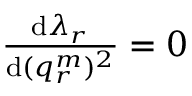Convert formula to latex. <formula><loc_0><loc_0><loc_500><loc_500>\begin{array} { r } { \frac { d \lambda _ { r } } { d ( q _ { r } ^ { m } ) ^ { 2 } } = 0 } \end{array}</formula> 